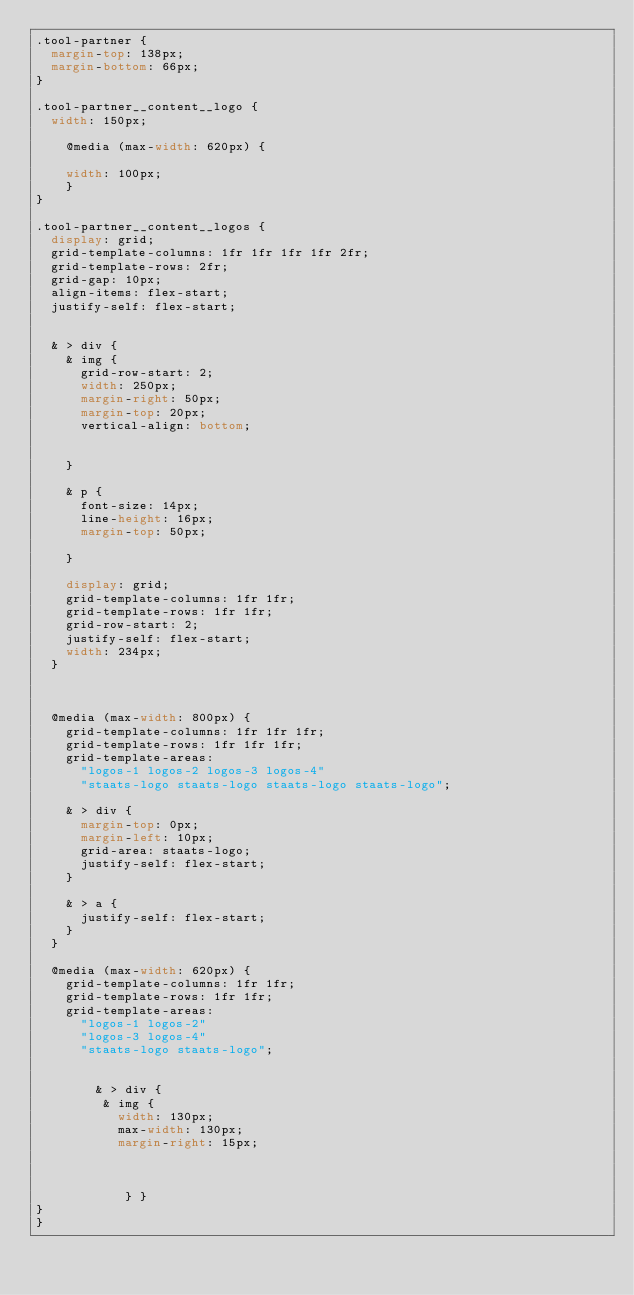Convert code to text. <code><loc_0><loc_0><loc_500><loc_500><_CSS_>.tool-partner {
  margin-top: 138px;
  margin-bottom: 66px;
}

.tool-partner__content__logo {
  width: 150px;
    
    @media (max-width: 620px) {
        
    width: 100px;
    }
}

.tool-partner__content__logos {
  display: grid;
  grid-template-columns: 1fr 1fr 1fr 1fr 2fr;
  grid-template-rows: 2fr;
  grid-gap: 10px;
  align-items: flex-start;
  justify-self: flex-start;


  & > div {
    & img {
      grid-row-start: 2;
      width: 250px;
      margin-right: 50px;     
      margin-top: 20px;
      vertical-align: bottom;

    
    }

    & p {
      font-size: 14px;
      line-height: 16px;
      margin-top: 50px;
      
    }
      
    display: grid;
    grid-template-columns: 1fr 1fr;
    grid-template-rows: 1fr 1fr;
    grid-row-start: 2;
    justify-self: flex-start;
    width: 234px;
  }
    


  @media (max-width: 800px) {
    grid-template-columns: 1fr 1fr 1fr;
    grid-template-rows: 1fr 1fr 1fr;
    grid-template-areas: 
      "logos-1 logos-2 logos-3 logos-4"
      "staats-logo staats-logo staats-logo staats-logo";

    & > div {
      margin-top: 0px;
      margin-left: 10px;
      grid-area: staats-logo;
      justify-self: flex-start;
    }

    & > a {
      justify-self: flex-start;
    }
  }

  @media (max-width: 620px) {
    grid-template-columns: 1fr 1fr;
    grid-template-rows: 1fr 1fr;
    grid-template-areas: 
      "logos-1 logos-2"
      "logos-3 logos-4"
      "staats-logo staats-logo";
      
      
        & > div {
         & img {
           width: 130px;
           max-width: 130px;     
           margin-right: 15px;
           
   

            } }
}
}</code> 